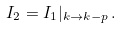Convert formula to latex. <formula><loc_0><loc_0><loc_500><loc_500>I _ { 2 } = I _ { 1 } | _ { k \rightarrow k - p } \, .</formula> 